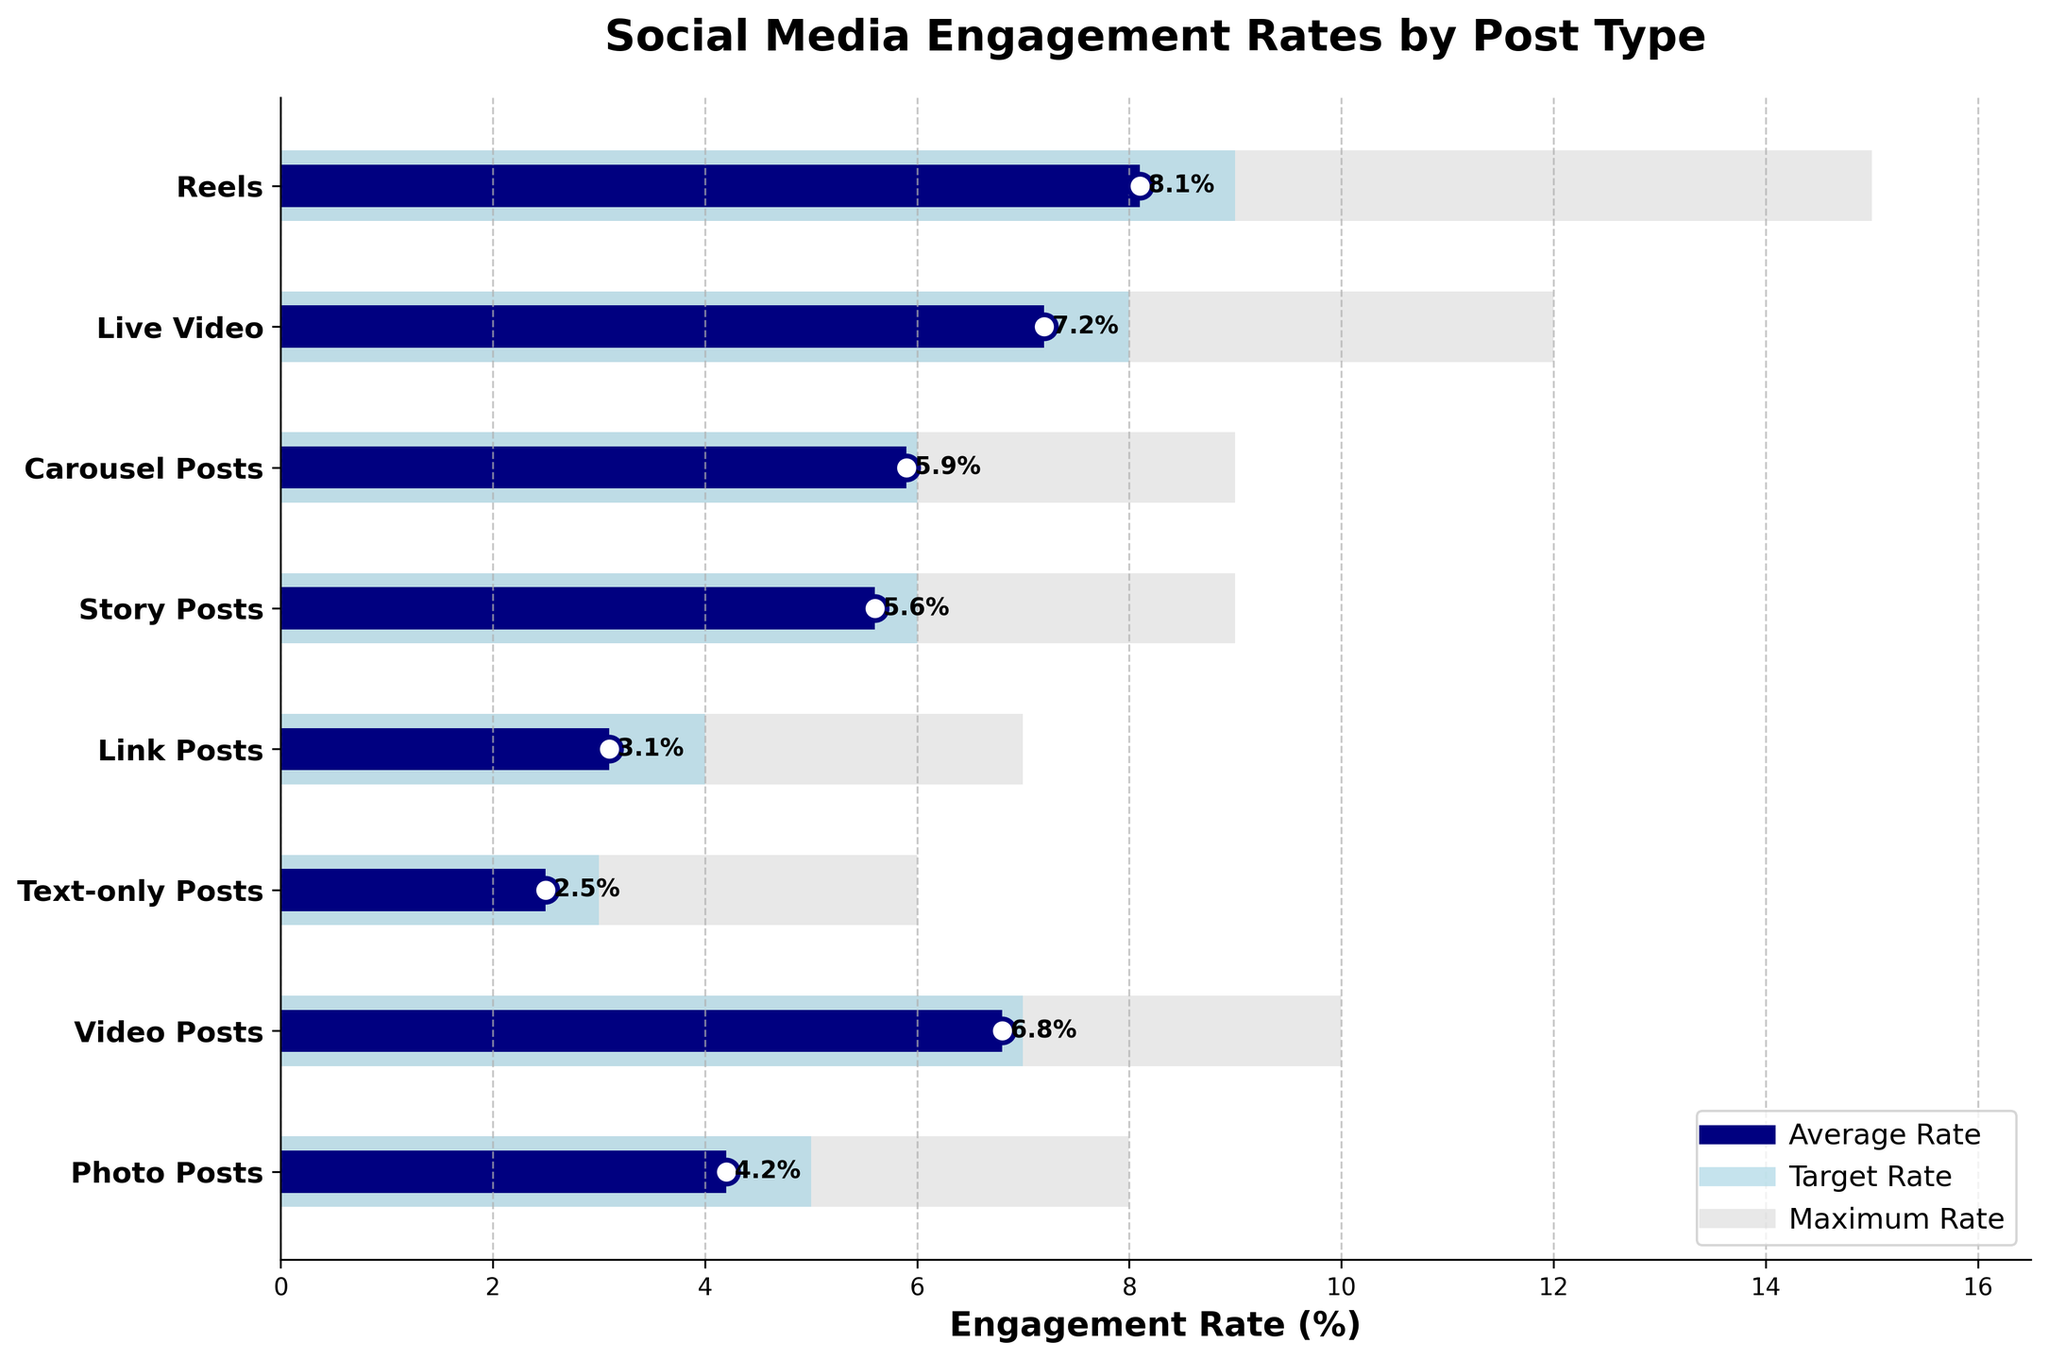what is the title of the plot? The title is usually placed at the top of the chart. In this case, the text at the top reads "Social Media Engagement Rates by Post Type".
Answer: Social Media Engagement Rates by Post Type which post type has the highest average engagement rate? By examining the bars for average engagement rate, the longest one corresponds to "Reels". Its bar extends the farthest on the x-axis, indicating the highest value.
Answer: Reels what is the average engagement rate for video posts? The blue bar representing the average engagement rate for "Video Posts" has a length extending to 6.8% on the x-axis.
Answer: 6.8% which post type has a lower average engagement rate, link posts or story posts? Comparing the blue bars for "Link Posts" and "Story Posts", Link Posts have a bar extending to 3.1% while Story Posts extend to 5.6%. Hence, Link Posts have a lower average engagement rate.
Answer: Link Posts how many post types have a target engagement rate equal to or above 6%? The light blue bars representing target rates for "Video Posts", "Story Posts", "Carousel Posts", "Live Video", and "Reels" all extend to or beyond the 6% mark. Counting these, we get five post types.
Answer: 5 what are the engagement rates for text-only posts and link posts? The dark blue bars for "Text-only Posts" and "Link Posts" show 2.5% and 3.1% respectively.
Answer: 2.5% and 3.1% which post type has a maximum engagement rate of 12%? The longest light grey bar extends to 12%, and it's associated with "Live Video".
Answer: Live Video what is the difference between the target rate and the average rate for carousel posts? The target engagement rate for "Carousel Posts" is 6%, and the average engagement rate is 5.9%. The difference between these two rates is 6 - 5.9 = 0.1%.
Answer: 0.1% if the average engagement rate for reels increased by 1%, what would the new engagement rate be? The current average engagement rate for "Reels" is 8.1%. Increasing this by 1% results in 8.1 + 1 = 9.1%.
Answer: 9.1% 